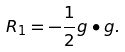Convert formula to latex. <formula><loc_0><loc_0><loc_500><loc_500>R _ { 1 } = - \frac { 1 } { 2 } g \bullet g .</formula> 